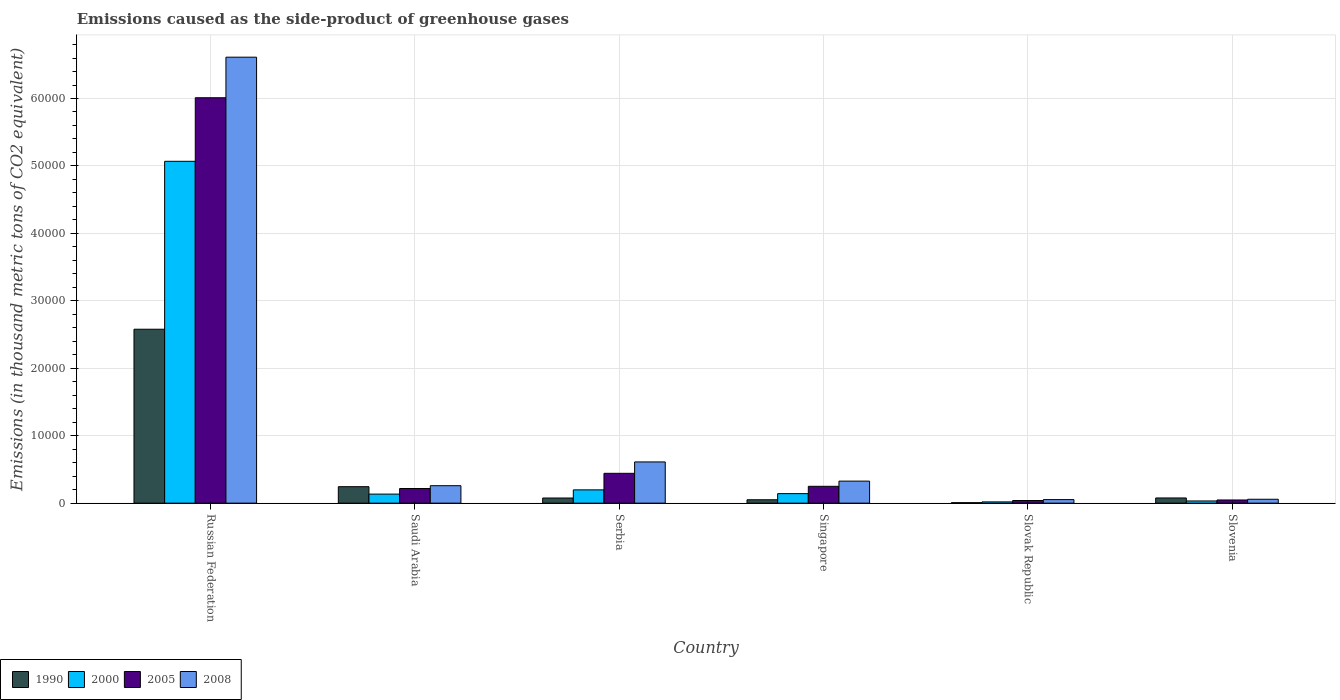How many different coloured bars are there?
Offer a terse response. 4. How many groups of bars are there?
Offer a very short reply. 6. Are the number of bars on each tick of the X-axis equal?
Offer a very short reply. Yes. What is the label of the 6th group of bars from the left?
Your response must be concise. Slovenia. In how many cases, is the number of bars for a given country not equal to the number of legend labels?
Provide a short and direct response. 0. What is the emissions caused as the side-product of greenhouse gases in 1990 in Slovak Republic?
Provide a succinct answer. 68.3. Across all countries, what is the maximum emissions caused as the side-product of greenhouse gases in 2000?
Your answer should be compact. 5.07e+04. Across all countries, what is the minimum emissions caused as the side-product of greenhouse gases in 2005?
Offer a terse response. 391.3. In which country was the emissions caused as the side-product of greenhouse gases in 1990 maximum?
Offer a very short reply. Russian Federation. In which country was the emissions caused as the side-product of greenhouse gases in 2008 minimum?
Your response must be concise. Slovak Republic. What is the total emissions caused as the side-product of greenhouse gases in 2000 in the graph?
Keep it short and to the point. 5.59e+04. What is the difference between the emissions caused as the side-product of greenhouse gases in 2008 in Serbia and that in Slovak Republic?
Your response must be concise. 5585.5. What is the difference between the emissions caused as the side-product of greenhouse gases in 2000 in Russian Federation and the emissions caused as the side-product of greenhouse gases in 2005 in Serbia?
Provide a succinct answer. 4.63e+04. What is the average emissions caused as the side-product of greenhouse gases in 1990 per country?
Your answer should be very brief. 5055.2. What is the difference between the emissions caused as the side-product of greenhouse gases of/in 2000 and emissions caused as the side-product of greenhouse gases of/in 1990 in Singapore?
Provide a succinct answer. 908.1. In how many countries, is the emissions caused as the side-product of greenhouse gases in 2005 greater than 6000 thousand metric tons?
Offer a terse response. 1. What is the ratio of the emissions caused as the side-product of greenhouse gases in 2008 in Russian Federation to that in Singapore?
Provide a succinct answer. 20.24. What is the difference between the highest and the second highest emissions caused as the side-product of greenhouse gases in 1990?
Give a very brief answer. -2.33e+04. What is the difference between the highest and the lowest emissions caused as the side-product of greenhouse gases in 2005?
Make the answer very short. 5.97e+04. Is the sum of the emissions caused as the side-product of greenhouse gases in 2008 in Saudi Arabia and Singapore greater than the maximum emissions caused as the side-product of greenhouse gases in 2005 across all countries?
Your answer should be very brief. No. Is it the case that in every country, the sum of the emissions caused as the side-product of greenhouse gases in 2008 and emissions caused as the side-product of greenhouse gases in 2000 is greater than the sum of emissions caused as the side-product of greenhouse gases in 1990 and emissions caused as the side-product of greenhouse gases in 2005?
Provide a succinct answer. No. What does the 2nd bar from the right in Slovak Republic represents?
Make the answer very short. 2005. How many bars are there?
Provide a short and direct response. 24. How many countries are there in the graph?
Ensure brevity in your answer.  6. Does the graph contain grids?
Provide a succinct answer. Yes. Where does the legend appear in the graph?
Give a very brief answer. Bottom left. How are the legend labels stacked?
Provide a succinct answer. Horizontal. What is the title of the graph?
Offer a very short reply. Emissions caused as the side-product of greenhouse gases. Does "1988" appear as one of the legend labels in the graph?
Your answer should be compact. No. What is the label or title of the X-axis?
Provide a short and direct response. Country. What is the label or title of the Y-axis?
Your answer should be very brief. Emissions (in thousand metric tons of CO2 equivalent). What is the Emissions (in thousand metric tons of CO2 equivalent) in 1990 in Russian Federation?
Your response must be concise. 2.58e+04. What is the Emissions (in thousand metric tons of CO2 equivalent) in 2000 in Russian Federation?
Offer a very short reply. 5.07e+04. What is the Emissions (in thousand metric tons of CO2 equivalent) of 2005 in Russian Federation?
Your answer should be very brief. 6.01e+04. What is the Emissions (in thousand metric tons of CO2 equivalent) in 2008 in Russian Federation?
Offer a very short reply. 6.61e+04. What is the Emissions (in thousand metric tons of CO2 equivalent) of 1990 in Saudi Arabia?
Your response must be concise. 2441.4. What is the Emissions (in thousand metric tons of CO2 equivalent) of 2000 in Saudi Arabia?
Your answer should be very brief. 1340.1. What is the Emissions (in thousand metric tons of CO2 equivalent) in 2005 in Saudi Arabia?
Give a very brief answer. 2170.7. What is the Emissions (in thousand metric tons of CO2 equivalent) of 2008 in Saudi Arabia?
Your response must be concise. 2588.3. What is the Emissions (in thousand metric tons of CO2 equivalent) of 1990 in Serbia?
Keep it short and to the point. 762.4. What is the Emissions (in thousand metric tons of CO2 equivalent) of 2000 in Serbia?
Make the answer very short. 1968.1. What is the Emissions (in thousand metric tons of CO2 equivalent) of 2005 in Serbia?
Make the answer very short. 4422.8. What is the Emissions (in thousand metric tons of CO2 equivalent) in 2008 in Serbia?
Offer a terse response. 6111.3. What is the Emissions (in thousand metric tons of CO2 equivalent) in 1990 in Singapore?
Offer a very short reply. 501.5. What is the Emissions (in thousand metric tons of CO2 equivalent) in 2000 in Singapore?
Your answer should be compact. 1409.6. What is the Emissions (in thousand metric tons of CO2 equivalent) of 2005 in Singapore?
Your response must be concise. 2496.4. What is the Emissions (in thousand metric tons of CO2 equivalent) of 2008 in Singapore?
Offer a very short reply. 3266.4. What is the Emissions (in thousand metric tons of CO2 equivalent) in 1990 in Slovak Republic?
Your answer should be very brief. 68.3. What is the Emissions (in thousand metric tons of CO2 equivalent) in 2000 in Slovak Republic?
Give a very brief answer. 185.6. What is the Emissions (in thousand metric tons of CO2 equivalent) in 2005 in Slovak Republic?
Give a very brief answer. 391.3. What is the Emissions (in thousand metric tons of CO2 equivalent) in 2008 in Slovak Republic?
Ensure brevity in your answer.  525.8. What is the Emissions (in thousand metric tons of CO2 equivalent) of 1990 in Slovenia?
Keep it short and to the point. 769. What is the Emissions (in thousand metric tons of CO2 equivalent) of 2000 in Slovenia?
Keep it short and to the point. 323.3. What is the Emissions (in thousand metric tons of CO2 equivalent) in 2005 in Slovenia?
Make the answer very short. 468.9. What is the Emissions (in thousand metric tons of CO2 equivalent) in 2008 in Slovenia?
Offer a terse response. 576.7. Across all countries, what is the maximum Emissions (in thousand metric tons of CO2 equivalent) of 1990?
Keep it short and to the point. 2.58e+04. Across all countries, what is the maximum Emissions (in thousand metric tons of CO2 equivalent) in 2000?
Provide a short and direct response. 5.07e+04. Across all countries, what is the maximum Emissions (in thousand metric tons of CO2 equivalent) in 2005?
Ensure brevity in your answer.  6.01e+04. Across all countries, what is the maximum Emissions (in thousand metric tons of CO2 equivalent) in 2008?
Your answer should be very brief. 6.61e+04. Across all countries, what is the minimum Emissions (in thousand metric tons of CO2 equivalent) in 1990?
Give a very brief answer. 68.3. Across all countries, what is the minimum Emissions (in thousand metric tons of CO2 equivalent) in 2000?
Your response must be concise. 185.6. Across all countries, what is the minimum Emissions (in thousand metric tons of CO2 equivalent) of 2005?
Make the answer very short. 391.3. Across all countries, what is the minimum Emissions (in thousand metric tons of CO2 equivalent) of 2008?
Give a very brief answer. 525.8. What is the total Emissions (in thousand metric tons of CO2 equivalent) in 1990 in the graph?
Keep it short and to the point. 3.03e+04. What is the total Emissions (in thousand metric tons of CO2 equivalent) in 2000 in the graph?
Your response must be concise. 5.59e+04. What is the total Emissions (in thousand metric tons of CO2 equivalent) of 2005 in the graph?
Your answer should be compact. 7.01e+04. What is the total Emissions (in thousand metric tons of CO2 equivalent) of 2008 in the graph?
Provide a short and direct response. 7.92e+04. What is the difference between the Emissions (in thousand metric tons of CO2 equivalent) in 1990 in Russian Federation and that in Saudi Arabia?
Your answer should be compact. 2.33e+04. What is the difference between the Emissions (in thousand metric tons of CO2 equivalent) of 2000 in Russian Federation and that in Saudi Arabia?
Provide a short and direct response. 4.93e+04. What is the difference between the Emissions (in thousand metric tons of CO2 equivalent) in 2005 in Russian Federation and that in Saudi Arabia?
Offer a terse response. 5.79e+04. What is the difference between the Emissions (in thousand metric tons of CO2 equivalent) in 2008 in Russian Federation and that in Saudi Arabia?
Provide a succinct answer. 6.35e+04. What is the difference between the Emissions (in thousand metric tons of CO2 equivalent) in 1990 in Russian Federation and that in Serbia?
Make the answer very short. 2.50e+04. What is the difference between the Emissions (in thousand metric tons of CO2 equivalent) of 2000 in Russian Federation and that in Serbia?
Give a very brief answer. 4.87e+04. What is the difference between the Emissions (in thousand metric tons of CO2 equivalent) of 2005 in Russian Federation and that in Serbia?
Keep it short and to the point. 5.57e+04. What is the difference between the Emissions (in thousand metric tons of CO2 equivalent) of 2008 in Russian Federation and that in Serbia?
Keep it short and to the point. 6.00e+04. What is the difference between the Emissions (in thousand metric tons of CO2 equivalent) of 1990 in Russian Federation and that in Singapore?
Give a very brief answer. 2.53e+04. What is the difference between the Emissions (in thousand metric tons of CO2 equivalent) in 2000 in Russian Federation and that in Singapore?
Ensure brevity in your answer.  4.93e+04. What is the difference between the Emissions (in thousand metric tons of CO2 equivalent) in 2005 in Russian Federation and that in Singapore?
Provide a short and direct response. 5.76e+04. What is the difference between the Emissions (in thousand metric tons of CO2 equivalent) in 2008 in Russian Federation and that in Singapore?
Offer a very short reply. 6.29e+04. What is the difference between the Emissions (in thousand metric tons of CO2 equivalent) in 1990 in Russian Federation and that in Slovak Republic?
Provide a succinct answer. 2.57e+04. What is the difference between the Emissions (in thousand metric tons of CO2 equivalent) in 2000 in Russian Federation and that in Slovak Republic?
Keep it short and to the point. 5.05e+04. What is the difference between the Emissions (in thousand metric tons of CO2 equivalent) in 2005 in Russian Federation and that in Slovak Republic?
Ensure brevity in your answer.  5.97e+04. What is the difference between the Emissions (in thousand metric tons of CO2 equivalent) of 2008 in Russian Federation and that in Slovak Republic?
Give a very brief answer. 6.56e+04. What is the difference between the Emissions (in thousand metric tons of CO2 equivalent) of 1990 in Russian Federation and that in Slovenia?
Provide a short and direct response. 2.50e+04. What is the difference between the Emissions (in thousand metric tons of CO2 equivalent) in 2000 in Russian Federation and that in Slovenia?
Offer a terse response. 5.04e+04. What is the difference between the Emissions (in thousand metric tons of CO2 equivalent) in 2005 in Russian Federation and that in Slovenia?
Provide a short and direct response. 5.96e+04. What is the difference between the Emissions (in thousand metric tons of CO2 equivalent) in 2008 in Russian Federation and that in Slovenia?
Keep it short and to the point. 6.56e+04. What is the difference between the Emissions (in thousand metric tons of CO2 equivalent) of 1990 in Saudi Arabia and that in Serbia?
Keep it short and to the point. 1679. What is the difference between the Emissions (in thousand metric tons of CO2 equivalent) in 2000 in Saudi Arabia and that in Serbia?
Ensure brevity in your answer.  -628. What is the difference between the Emissions (in thousand metric tons of CO2 equivalent) in 2005 in Saudi Arabia and that in Serbia?
Make the answer very short. -2252.1. What is the difference between the Emissions (in thousand metric tons of CO2 equivalent) in 2008 in Saudi Arabia and that in Serbia?
Provide a succinct answer. -3523. What is the difference between the Emissions (in thousand metric tons of CO2 equivalent) of 1990 in Saudi Arabia and that in Singapore?
Offer a very short reply. 1939.9. What is the difference between the Emissions (in thousand metric tons of CO2 equivalent) of 2000 in Saudi Arabia and that in Singapore?
Provide a succinct answer. -69.5. What is the difference between the Emissions (in thousand metric tons of CO2 equivalent) of 2005 in Saudi Arabia and that in Singapore?
Offer a very short reply. -325.7. What is the difference between the Emissions (in thousand metric tons of CO2 equivalent) of 2008 in Saudi Arabia and that in Singapore?
Offer a terse response. -678.1. What is the difference between the Emissions (in thousand metric tons of CO2 equivalent) in 1990 in Saudi Arabia and that in Slovak Republic?
Provide a short and direct response. 2373.1. What is the difference between the Emissions (in thousand metric tons of CO2 equivalent) of 2000 in Saudi Arabia and that in Slovak Republic?
Offer a very short reply. 1154.5. What is the difference between the Emissions (in thousand metric tons of CO2 equivalent) of 2005 in Saudi Arabia and that in Slovak Republic?
Your answer should be very brief. 1779.4. What is the difference between the Emissions (in thousand metric tons of CO2 equivalent) of 2008 in Saudi Arabia and that in Slovak Republic?
Give a very brief answer. 2062.5. What is the difference between the Emissions (in thousand metric tons of CO2 equivalent) in 1990 in Saudi Arabia and that in Slovenia?
Provide a short and direct response. 1672.4. What is the difference between the Emissions (in thousand metric tons of CO2 equivalent) of 2000 in Saudi Arabia and that in Slovenia?
Your answer should be compact. 1016.8. What is the difference between the Emissions (in thousand metric tons of CO2 equivalent) in 2005 in Saudi Arabia and that in Slovenia?
Your answer should be very brief. 1701.8. What is the difference between the Emissions (in thousand metric tons of CO2 equivalent) of 2008 in Saudi Arabia and that in Slovenia?
Your answer should be compact. 2011.6. What is the difference between the Emissions (in thousand metric tons of CO2 equivalent) in 1990 in Serbia and that in Singapore?
Your answer should be very brief. 260.9. What is the difference between the Emissions (in thousand metric tons of CO2 equivalent) of 2000 in Serbia and that in Singapore?
Ensure brevity in your answer.  558.5. What is the difference between the Emissions (in thousand metric tons of CO2 equivalent) of 2005 in Serbia and that in Singapore?
Provide a short and direct response. 1926.4. What is the difference between the Emissions (in thousand metric tons of CO2 equivalent) of 2008 in Serbia and that in Singapore?
Keep it short and to the point. 2844.9. What is the difference between the Emissions (in thousand metric tons of CO2 equivalent) of 1990 in Serbia and that in Slovak Republic?
Offer a terse response. 694.1. What is the difference between the Emissions (in thousand metric tons of CO2 equivalent) of 2000 in Serbia and that in Slovak Republic?
Offer a very short reply. 1782.5. What is the difference between the Emissions (in thousand metric tons of CO2 equivalent) in 2005 in Serbia and that in Slovak Republic?
Make the answer very short. 4031.5. What is the difference between the Emissions (in thousand metric tons of CO2 equivalent) in 2008 in Serbia and that in Slovak Republic?
Your answer should be compact. 5585.5. What is the difference between the Emissions (in thousand metric tons of CO2 equivalent) of 1990 in Serbia and that in Slovenia?
Give a very brief answer. -6.6. What is the difference between the Emissions (in thousand metric tons of CO2 equivalent) of 2000 in Serbia and that in Slovenia?
Provide a succinct answer. 1644.8. What is the difference between the Emissions (in thousand metric tons of CO2 equivalent) of 2005 in Serbia and that in Slovenia?
Offer a terse response. 3953.9. What is the difference between the Emissions (in thousand metric tons of CO2 equivalent) of 2008 in Serbia and that in Slovenia?
Your response must be concise. 5534.6. What is the difference between the Emissions (in thousand metric tons of CO2 equivalent) in 1990 in Singapore and that in Slovak Republic?
Provide a short and direct response. 433.2. What is the difference between the Emissions (in thousand metric tons of CO2 equivalent) of 2000 in Singapore and that in Slovak Republic?
Provide a short and direct response. 1224. What is the difference between the Emissions (in thousand metric tons of CO2 equivalent) of 2005 in Singapore and that in Slovak Republic?
Provide a succinct answer. 2105.1. What is the difference between the Emissions (in thousand metric tons of CO2 equivalent) of 2008 in Singapore and that in Slovak Republic?
Make the answer very short. 2740.6. What is the difference between the Emissions (in thousand metric tons of CO2 equivalent) in 1990 in Singapore and that in Slovenia?
Your answer should be very brief. -267.5. What is the difference between the Emissions (in thousand metric tons of CO2 equivalent) in 2000 in Singapore and that in Slovenia?
Provide a short and direct response. 1086.3. What is the difference between the Emissions (in thousand metric tons of CO2 equivalent) in 2005 in Singapore and that in Slovenia?
Provide a short and direct response. 2027.5. What is the difference between the Emissions (in thousand metric tons of CO2 equivalent) of 2008 in Singapore and that in Slovenia?
Keep it short and to the point. 2689.7. What is the difference between the Emissions (in thousand metric tons of CO2 equivalent) of 1990 in Slovak Republic and that in Slovenia?
Provide a short and direct response. -700.7. What is the difference between the Emissions (in thousand metric tons of CO2 equivalent) of 2000 in Slovak Republic and that in Slovenia?
Your answer should be very brief. -137.7. What is the difference between the Emissions (in thousand metric tons of CO2 equivalent) in 2005 in Slovak Republic and that in Slovenia?
Offer a very short reply. -77.6. What is the difference between the Emissions (in thousand metric tons of CO2 equivalent) in 2008 in Slovak Republic and that in Slovenia?
Provide a succinct answer. -50.9. What is the difference between the Emissions (in thousand metric tons of CO2 equivalent) of 1990 in Russian Federation and the Emissions (in thousand metric tons of CO2 equivalent) of 2000 in Saudi Arabia?
Your response must be concise. 2.44e+04. What is the difference between the Emissions (in thousand metric tons of CO2 equivalent) of 1990 in Russian Federation and the Emissions (in thousand metric tons of CO2 equivalent) of 2005 in Saudi Arabia?
Your answer should be compact. 2.36e+04. What is the difference between the Emissions (in thousand metric tons of CO2 equivalent) in 1990 in Russian Federation and the Emissions (in thousand metric tons of CO2 equivalent) in 2008 in Saudi Arabia?
Give a very brief answer. 2.32e+04. What is the difference between the Emissions (in thousand metric tons of CO2 equivalent) in 2000 in Russian Federation and the Emissions (in thousand metric tons of CO2 equivalent) in 2005 in Saudi Arabia?
Make the answer very short. 4.85e+04. What is the difference between the Emissions (in thousand metric tons of CO2 equivalent) in 2000 in Russian Federation and the Emissions (in thousand metric tons of CO2 equivalent) in 2008 in Saudi Arabia?
Your response must be concise. 4.81e+04. What is the difference between the Emissions (in thousand metric tons of CO2 equivalent) of 2005 in Russian Federation and the Emissions (in thousand metric tons of CO2 equivalent) of 2008 in Saudi Arabia?
Make the answer very short. 5.75e+04. What is the difference between the Emissions (in thousand metric tons of CO2 equivalent) in 1990 in Russian Federation and the Emissions (in thousand metric tons of CO2 equivalent) in 2000 in Serbia?
Ensure brevity in your answer.  2.38e+04. What is the difference between the Emissions (in thousand metric tons of CO2 equivalent) in 1990 in Russian Federation and the Emissions (in thousand metric tons of CO2 equivalent) in 2005 in Serbia?
Provide a short and direct response. 2.14e+04. What is the difference between the Emissions (in thousand metric tons of CO2 equivalent) in 1990 in Russian Federation and the Emissions (in thousand metric tons of CO2 equivalent) in 2008 in Serbia?
Your response must be concise. 1.97e+04. What is the difference between the Emissions (in thousand metric tons of CO2 equivalent) in 2000 in Russian Federation and the Emissions (in thousand metric tons of CO2 equivalent) in 2005 in Serbia?
Your response must be concise. 4.63e+04. What is the difference between the Emissions (in thousand metric tons of CO2 equivalent) in 2000 in Russian Federation and the Emissions (in thousand metric tons of CO2 equivalent) in 2008 in Serbia?
Offer a very short reply. 4.46e+04. What is the difference between the Emissions (in thousand metric tons of CO2 equivalent) in 2005 in Russian Federation and the Emissions (in thousand metric tons of CO2 equivalent) in 2008 in Serbia?
Provide a succinct answer. 5.40e+04. What is the difference between the Emissions (in thousand metric tons of CO2 equivalent) in 1990 in Russian Federation and the Emissions (in thousand metric tons of CO2 equivalent) in 2000 in Singapore?
Your answer should be very brief. 2.44e+04. What is the difference between the Emissions (in thousand metric tons of CO2 equivalent) of 1990 in Russian Federation and the Emissions (in thousand metric tons of CO2 equivalent) of 2005 in Singapore?
Offer a very short reply. 2.33e+04. What is the difference between the Emissions (in thousand metric tons of CO2 equivalent) in 1990 in Russian Federation and the Emissions (in thousand metric tons of CO2 equivalent) in 2008 in Singapore?
Keep it short and to the point. 2.25e+04. What is the difference between the Emissions (in thousand metric tons of CO2 equivalent) of 2000 in Russian Federation and the Emissions (in thousand metric tons of CO2 equivalent) of 2005 in Singapore?
Make the answer very short. 4.82e+04. What is the difference between the Emissions (in thousand metric tons of CO2 equivalent) in 2000 in Russian Federation and the Emissions (in thousand metric tons of CO2 equivalent) in 2008 in Singapore?
Offer a very short reply. 4.74e+04. What is the difference between the Emissions (in thousand metric tons of CO2 equivalent) of 2005 in Russian Federation and the Emissions (in thousand metric tons of CO2 equivalent) of 2008 in Singapore?
Provide a succinct answer. 5.68e+04. What is the difference between the Emissions (in thousand metric tons of CO2 equivalent) in 1990 in Russian Federation and the Emissions (in thousand metric tons of CO2 equivalent) in 2000 in Slovak Republic?
Make the answer very short. 2.56e+04. What is the difference between the Emissions (in thousand metric tons of CO2 equivalent) in 1990 in Russian Federation and the Emissions (in thousand metric tons of CO2 equivalent) in 2005 in Slovak Republic?
Offer a terse response. 2.54e+04. What is the difference between the Emissions (in thousand metric tons of CO2 equivalent) in 1990 in Russian Federation and the Emissions (in thousand metric tons of CO2 equivalent) in 2008 in Slovak Republic?
Ensure brevity in your answer.  2.53e+04. What is the difference between the Emissions (in thousand metric tons of CO2 equivalent) in 2000 in Russian Federation and the Emissions (in thousand metric tons of CO2 equivalent) in 2005 in Slovak Republic?
Provide a succinct answer. 5.03e+04. What is the difference between the Emissions (in thousand metric tons of CO2 equivalent) in 2000 in Russian Federation and the Emissions (in thousand metric tons of CO2 equivalent) in 2008 in Slovak Republic?
Make the answer very short. 5.02e+04. What is the difference between the Emissions (in thousand metric tons of CO2 equivalent) in 2005 in Russian Federation and the Emissions (in thousand metric tons of CO2 equivalent) in 2008 in Slovak Republic?
Provide a succinct answer. 5.96e+04. What is the difference between the Emissions (in thousand metric tons of CO2 equivalent) of 1990 in Russian Federation and the Emissions (in thousand metric tons of CO2 equivalent) of 2000 in Slovenia?
Offer a very short reply. 2.55e+04. What is the difference between the Emissions (in thousand metric tons of CO2 equivalent) of 1990 in Russian Federation and the Emissions (in thousand metric tons of CO2 equivalent) of 2005 in Slovenia?
Your response must be concise. 2.53e+04. What is the difference between the Emissions (in thousand metric tons of CO2 equivalent) in 1990 in Russian Federation and the Emissions (in thousand metric tons of CO2 equivalent) in 2008 in Slovenia?
Make the answer very short. 2.52e+04. What is the difference between the Emissions (in thousand metric tons of CO2 equivalent) in 2000 in Russian Federation and the Emissions (in thousand metric tons of CO2 equivalent) in 2005 in Slovenia?
Provide a short and direct response. 5.02e+04. What is the difference between the Emissions (in thousand metric tons of CO2 equivalent) in 2000 in Russian Federation and the Emissions (in thousand metric tons of CO2 equivalent) in 2008 in Slovenia?
Give a very brief answer. 5.01e+04. What is the difference between the Emissions (in thousand metric tons of CO2 equivalent) of 2005 in Russian Federation and the Emissions (in thousand metric tons of CO2 equivalent) of 2008 in Slovenia?
Offer a terse response. 5.95e+04. What is the difference between the Emissions (in thousand metric tons of CO2 equivalent) of 1990 in Saudi Arabia and the Emissions (in thousand metric tons of CO2 equivalent) of 2000 in Serbia?
Your answer should be compact. 473.3. What is the difference between the Emissions (in thousand metric tons of CO2 equivalent) of 1990 in Saudi Arabia and the Emissions (in thousand metric tons of CO2 equivalent) of 2005 in Serbia?
Provide a short and direct response. -1981.4. What is the difference between the Emissions (in thousand metric tons of CO2 equivalent) of 1990 in Saudi Arabia and the Emissions (in thousand metric tons of CO2 equivalent) of 2008 in Serbia?
Your response must be concise. -3669.9. What is the difference between the Emissions (in thousand metric tons of CO2 equivalent) in 2000 in Saudi Arabia and the Emissions (in thousand metric tons of CO2 equivalent) in 2005 in Serbia?
Your answer should be very brief. -3082.7. What is the difference between the Emissions (in thousand metric tons of CO2 equivalent) of 2000 in Saudi Arabia and the Emissions (in thousand metric tons of CO2 equivalent) of 2008 in Serbia?
Your answer should be very brief. -4771.2. What is the difference between the Emissions (in thousand metric tons of CO2 equivalent) of 2005 in Saudi Arabia and the Emissions (in thousand metric tons of CO2 equivalent) of 2008 in Serbia?
Provide a succinct answer. -3940.6. What is the difference between the Emissions (in thousand metric tons of CO2 equivalent) of 1990 in Saudi Arabia and the Emissions (in thousand metric tons of CO2 equivalent) of 2000 in Singapore?
Offer a terse response. 1031.8. What is the difference between the Emissions (in thousand metric tons of CO2 equivalent) in 1990 in Saudi Arabia and the Emissions (in thousand metric tons of CO2 equivalent) in 2005 in Singapore?
Provide a succinct answer. -55. What is the difference between the Emissions (in thousand metric tons of CO2 equivalent) in 1990 in Saudi Arabia and the Emissions (in thousand metric tons of CO2 equivalent) in 2008 in Singapore?
Your response must be concise. -825. What is the difference between the Emissions (in thousand metric tons of CO2 equivalent) in 2000 in Saudi Arabia and the Emissions (in thousand metric tons of CO2 equivalent) in 2005 in Singapore?
Offer a very short reply. -1156.3. What is the difference between the Emissions (in thousand metric tons of CO2 equivalent) in 2000 in Saudi Arabia and the Emissions (in thousand metric tons of CO2 equivalent) in 2008 in Singapore?
Provide a short and direct response. -1926.3. What is the difference between the Emissions (in thousand metric tons of CO2 equivalent) of 2005 in Saudi Arabia and the Emissions (in thousand metric tons of CO2 equivalent) of 2008 in Singapore?
Provide a succinct answer. -1095.7. What is the difference between the Emissions (in thousand metric tons of CO2 equivalent) of 1990 in Saudi Arabia and the Emissions (in thousand metric tons of CO2 equivalent) of 2000 in Slovak Republic?
Keep it short and to the point. 2255.8. What is the difference between the Emissions (in thousand metric tons of CO2 equivalent) of 1990 in Saudi Arabia and the Emissions (in thousand metric tons of CO2 equivalent) of 2005 in Slovak Republic?
Keep it short and to the point. 2050.1. What is the difference between the Emissions (in thousand metric tons of CO2 equivalent) of 1990 in Saudi Arabia and the Emissions (in thousand metric tons of CO2 equivalent) of 2008 in Slovak Republic?
Provide a succinct answer. 1915.6. What is the difference between the Emissions (in thousand metric tons of CO2 equivalent) of 2000 in Saudi Arabia and the Emissions (in thousand metric tons of CO2 equivalent) of 2005 in Slovak Republic?
Offer a terse response. 948.8. What is the difference between the Emissions (in thousand metric tons of CO2 equivalent) in 2000 in Saudi Arabia and the Emissions (in thousand metric tons of CO2 equivalent) in 2008 in Slovak Republic?
Your answer should be compact. 814.3. What is the difference between the Emissions (in thousand metric tons of CO2 equivalent) in 2005 in Saudi Arabia and the Emissions (in thousand metric tons of CO2 equivalent) in 2008 in Slovak Republic?
Give a very brief answer. 1644.9. What is the difference between the Emissions (in thousand metric tons of CO2 equivalent) of 1990 in Saudi Arabia and the Emissions (in thousand metric tons of CO2 equivalent) of 2000 in Slovenia?
Provide a succinct answer. 2118.1. What is the difference between the Emissions (in thousand metric tons of CO2 equivalent) in 1990 in Saudi Arabia and the Emissions (in thousand metric tons of CO2 equivalent) in 2005 in Slovenia?
Make the answer very short. 1972.5. What is the difference between the Emissions (in thousand metric tons of CO2 equivalent) in 1990 in Saudi Arabia and the Emissions (in thousand metric tons of CO2 equivalent) in 2008 in Slovenia?
Make the answer very short. 1864.7. What is the difference between the Emissions (in thousand metric tons of CO2 equivalent) of 2000 in Saudi Arabia and the Emissions (in thousand metric tons of CO2 equivalent) of 2005 in Slovenia?
Your answer should be very brief. 871.2. What is the difference between the Emissions (in thousand metric tons of CO2 equivalent) in 2000 in Saudi Arabia and the Emissions (in thousand metric tons of CO2 equivalent) in 2008 in Slovenia?
Your response must be concise. 763.4. What is the difference between the Emissions (in thousand metric tons of CO2 equivalent) in 2005 in Saudi Arabia and the Emissions (in thousand metric tons of CO2 equivalent) in 2008 in Slovenia?
Give a very brief answer. 1594. What is the difference between the Emissions (in thousand metric tons of CO2 equivalent) in 1990 in Serbia and the Emissions (in thousand metric tons of CO2 equivalent) in 2000 in Singapore?
Give a very brief answer. -647.2. What is the difference between the Emissions (in thousand metric tons of CO2 equivalent) of 1990 in Serbia and the Emissions (in thousand metric tons of CO2 equivalent) of 2005 in Singapore?
Provide a succinct answer. -1734. What is the difference between the Emissions (in thousand metric tons of CO2 equivalent) of 1990 in Serbia and the Emissions (in thousand metric tons of CO2 equivalent) of 2008 in Singapore?
Ensure brevity in your answer.  -2504. What is the difference between the Emissions (in thousand metric tons of CO2 equivalent) in 2000 in Serbia and the Emissions (in thousand metric tons of CO2 equivalent) in 2005 in Singapore?
Your answer should be very brief. -528.3. What is the difference between the Emissions (in thousand metric tons of CO2 equivalent) in 2000 in Serbia and the Emissions (in thousand metric tons of CO2 equivalent) in 2008 in Singapore?
Provide a succinct answer. -1298.3. What is the difference between the Emissions (in thousand metric tons of CO2 equivalent) of 2005 in Serbia and the Emissions (in thousand metric tons of CO2 equivalent) of 2008 in Singapore?
Give a very brief answer. 1156.4. What is the difference between the Emissions (in thousand metric tons of CO2 equivalent) in 1990 in Serbia and the Emissions (in thousand metric tons of CO2 equivalent) in 2000 in Slovak Republic?
Provide a succinct answer. 576.8. What is the difference between the Emissions (in thousand metric tons of CO2 equivalent) in 1990 in Serbia and the Emissions (in thousand metric tons of CO2 equivalent) in 2005 in Slovak Republic?
Your answer should be very brief. 371.1. What is the difference between the Emissions (in thousand metric tons of CO2 equivalent) of 1990 in Serbia and the Emissions (in thousand metric tons of CO2 equivalent) of 2008 in Slovak Republic?
Keep it short and to the point. 236.6. What is the difference between the Emissions (in thousand metric tons of CO2 equivalent) in 2000 in Serbia and the Emissions (in thousand metric tons of CO2 equivalent) in 2005 in Slovak Republic?
Your answer should be compact. 1576.8. What is the difference between the Emissions (in thousand metric tons of CO2 equivalent) in 2000 in Serbia and the Emissions (in thousand metric tons of CO2 equivalent) in 2008 in Slovak Republic?
Offer a terse response. 1442.3. What is the difference between the Emissions (in thousand metric tons of CO2 equivalent) in 2005 in Serbia and the Emissions (in thousand metric tons of CO2 equivalent) in 2008 in Slovak Republic?
Offer a very short reply. 3897. What is the difference between the Emissions (in thousand metric tons of CO2 equivalent) of 1990 in Serbia and the Emissions (in thousand metric tons of CO2 equivalent) of 2000 in Slovenia?
Your response must be concise. 439.1. What is the difference between the Emissions (in thousand metric tons of CO2 equivalent) of 1990 in Serbia and the Emissions (in thousand metric tons of CO2 equivalent) of 2005 in Slovenia?
Keep it short and to the point. 293.5. What is the difference between the Emissions (in thousand metric tons of CO2 equivalent) in 1990 in Serbia and the Emissions (in thousand metric tons of CO2 equivalent) in 2008 in Slovenia?
Offer a very short reply. 185.7. What is the difference between the Emissions (in thousand metric tons of CO2 equivalent) in 2000 in Serbia and the Emissions (in thousand metric tons of CO2 equivalent) in 2005 in Slovenia?
Provide a succinct answer. 1499.2. What is the difference between the Emissions (in thousand metric tons of CO2 equivalent) in 2000 in Serbia and the Emissions (in thousand metric tons of CO2 equivalent) in 2008 in Slovenia?
Offer a very short reply. 1391.4. What is the difference between the Emissions (in thousand metric tons of CO2 equivalent) in 2005 in Serbia and the Emissions (in thousand metric tons of CO2 equivalent) in 2008 in Slovenia?
Keep it short and to the point. 3846.1. What is the difference between the Emissions (in thousand metric tons of CO2 equivalent) of 1990 in Singapore and the Emissions (in thousand metric tons of CO2 equivalent) of 2000 in Slovak Republic?
Your response must be concise. 315.9. What is the difference between the Emissions (in thousand metric tons of CO2 equivalent) of 1990 in Singapore and the Emissions (in thousand metric tons of CO2 equivalent) of 2005 in Slovak Republic?
Offer a very short reply. 110.2. What is the difference between the Emissions (in thousand metric tons of CO2 equivalent) of 1990 in Singapore and the Emissions (in thousand metric tons of CO2 equivalent) of 2008 in Slovak Republic?
Offer a very short reply. -24.3. What is the difference between the Emissions (in thousand metric tons of CO2 equivalent) of 2000 in Singapore and the Emissions (in thousand metric tons of CO2 equivalent) of 2005 in Slovak Republic?
Provide a short and direct response. 1018.3. What is the difference between the Emissions (in thousand metric tons of CO2 equivalent) in 2000 in Singapore and the Emissions (in thousand metric tons of CO2 equivalent) in 2008 in Slovak Republic?
Offer a very short reply. 883.8. What is the difference between the Emissions (in thousand metric tons of CO2 equivalent) of 2005 in Singapore and the Emissions (in thousand metric tons of CO2 equivalent) of 2008 in Slovak Republic?
Keep it short and to the point. 1970.6. What is the difference between the Emissions (in thousand metric tons of CO2 equivalent) in 1990 in Singapore and the Emissions (in thousand metric tons of CO2 equivalent) in 2000 in Slovenia?
Your answer should be compact. 178.2. What is the difference between the Emissions (in thousand metric tons of CO2 equivalent) in 1990 in Singapore and the Emissions (in thousand metric tons of CO2 equivalent) in 2005 in Slovenia?
Keep it short and to the point. 32.6. What is the difference between the Emissions (in thousand metric tons of CO2 equivalent) in 1990 in Singapore and the Emissions (in thousand metric tons of CO2 equivalent) in 2008 in Slovenia?
Provide a short and direct response. -75.2. What is the difference between the Emissions (in thousand metric tons of CO2 equivalent) of 2000 in Singapore and the Emissions (in thousand metric tons of CO2 equivalent) of 2005 in Slovenia?
Provide a short and direct response. 940.7. What is the difference between the Emissions (in thousand metric tons of CO2 equivalent) in 2000 in Singapore and the Emissions (in thousand metric tons of CO2 equivalent) in 2008 in Slovenia?
Provide a succinct answer. 832.9. What is the difference between the Emissions (in thousand metric tons of CO2 equivalent) of 2005 in Singapore and the Emissions (in thousand metric tons of CO2 equivalent) of 2008 in Slovenia?
Offer a terse response. 1919.7. What is the difference between the Emissions (in thousand metric tons of CO2 equivalent) in 1990 in Slovak Republic and the Emissions (in thousand metric tons of CO2 equivalent) in 2000 in Slovenia?
Provide a succinct answer. -255. What is the difference between the Emissions (in thousand metric tons of CO2 equivalent) in 1990 in Slovak Republic and the Emissions (in thousand metric tons of CO2 equivalent) in 2005 in Slovenia?
Provide a short and direct response. -400.6. What is the difference between the Emissions (in thousand metric tons of CO2 equivalent) of 1990 in Slovak Republic and the Emissions (in thousand metric tons of CO2 equivalent) of 2008 in Slovenia?
Your answer should be compact. -508.4. What is the difference between the Emissions (in thousand metric tons of CO2 equivalent) in 2000 in Slovak Republic and the Emissions (in thousand metric tons of CO2 equivalent) in 2005 in Slovenia?
Offer a very short reply. -283.3. What is the difference between the Emissions (in thousand metric tons of CO2 equivalent) of 2000 in Slovak Republic and the Emissions (in thousand metric tons of CO2 equivalent) of 2008 in Slovenia?
Keep it short and to the point. -391.1. What is the difference between the Emissions (in thousand metric tons of CO2 equivalent) in 2005 in Slovak Republic and the Emissions (in thousand metric tons of CO2 equivalent) in 2008 in Slovenia?
Offer a terse response. -185.4. What is the average Emissions (in thousand metric tons of CO2 equivalent) of 1990 per country?
Ensure brevity in your answer.  5055.2. What is the average Emissions (in thousand metric tons of CO2 equivalent) of 2000 per country?
Provide a short and direct response. 9319.12. What is the average Emissions (in thousand metric tons of CO2 equivalent) of 2005 per country?
Your answer should be very brief. 1.17e+04. What is the average Emissions (in thousand metric tons of CO2 equivalent) in 2008 per country?
Your answer should be very brief. 1.32e+04. What is the difference between the Emissions (in thousand metric tons of CO2 equivalent) in 1990 and Emissions (in thousand metric tons of CO2 equivalent) in 2000 in Russian Federation?
Your answer should be very brief. -2.49e+04. What is the difference between the Emissions (in thousand metric tons of CO2 equivalent) of 1990 and Emissions (in thousand metric tons of CO2 equivalent) of 2005 in Russian Federation?
Ensure brevity in your answer.  -3.43e+04. What is the difference between the Emissions (in thousand metric tons of CO2 equivalent) of 1990 and Emissions (in thousand metric tons of CO2 equivalent) of 2008 in Russian Federation?
Your response must be concise. -4.03e+04. What is the difference between the Emissions (in thousand metric tons of CO2 equivalent) of 2000 and Emissions (in thousand metric tons of CO2 equivalent) of 2005 in Russian Federation?
Make the answer very short. -9424.5. What is the difference between the Emissions (in thousand metric tons of CO2 equivalent) of 2000 and Emissions (in thousand metric tons of CO2 equivalent) of 2008 in Russian Federation?
Offer a very short reply. -1.54e+04. What is the difference between the Emissions (in thousand metric tons of CO2 equivalent) in 2005 and Emissions (in thousand metric tons of CO2 equivalent) in 2008 in Russian Federation?
Give a very brief answer. -6015. What is the difference between the Emissions (in thousand metric tons of CO2 equivalent) in 1990 and Emissions (in thousand metric tons of CO2 equivalent) in 2000 in Saudi Arabia?
Your response must be concise. 1101.3. What is the difference between the Emissions (in thousand metric tons of CO2 equivalent) in 1990 and Emissions (in thousand metric tons of CO2 equivalent) in 2005 in Saudi Arabia?
Offer a very short reply. 270.7. What is the difference between the Emissions (in thousand metric tons of CO2 equivalent) in 1990 and Emissions (in thousand metric tons of CO2 equivalent) in 2008 in Saudi Arabia?
Your response must be concise. -146.9. What is the difference between the Emissions (in thousand metric tons of CO2 equivalent) in 2000 and Emissions (in thousand metric tons of CO2 equivalent) in 2005 in Saudi Arabia?
Your answer should be very brief. -830.6. What is the difference between the Emissions (in thousand metric tons of CO2 equivalent) of 2000 and Emissions (in thousand metric tons of CO2 equivalent) of 2008 in Saudi Arabia?
Offer a very short reply. -1248.2. What is the difference between the Emissions (in thousand metric tons of CO2 equivalent) of 2005 and Emissions (in thousand metric tons of CO2 equivalent) of 2008 in Saudi Arabia?
Your answer should be very brief. -417.6. What is the difference between the Emissions (in thousand metric tons of CO2 equivalent) in 1990 and Emissions (in thousand metric tons of CO2 equivalent) in 2000 in Serbia?
Provide a succinct answer. -1205.7. What is the difference between the Emissions (in thousand metric tons of CO2 equivalent) of 1990 and Emissions (in thousand metric tons of CO2 equivalent) of 2005 in Serbia?
Offer a very short reply. -3660.4. What is the difference between the Emissions (in thousand metric tons of CO2 equivalent) in 1990 and Emissions (in thousand metric tons of CO2 equivalent) in 2008 in Serbia?
Offer a terse response. -5348.9. What is the difference between the Emissions (in thousand metric tons of CO2 equivalent) in 2000 and Emissions (in thousand metric tons of CO2 equivalent) in 2005 in Serbia?
Give a very brief answer. -2454.7. What is the difference between the Emissions (in thousand metric tons of CO2 equivalent) of 2000 and Emissions (in thousand metric tons of CO2 equivalent) of 2008 in Serbia?
Keep it short and to the point. -4143.2. What is the difference between the Emissions (in thousand metric tons of CO2 equivalent) in 2005 and Emissions (in thousand metric tons of CO2 equivalent) in 2008 in Serbia?
Give a very brief answer. -1688.5. What is the difference between the Emissions (in thousand metric tons of CO2 equivalent) in 1990 and Emissions (in thousand metric tons of CO2 equivalent) in 2000 in Singapore?
Your answer should be very brief. -908.1. What is the difference between the Emissions (in thousand metric tons of CO2 equivalent) in 1990 and Emissions (in thousand metric tons of CO2 equivalent) in 2005 in Singapore?
Provide a succinct answer. -1994.9. What is the difference between the Emissions (in thousand metric tons of CO2 equivalent) of 1990 and Emissions (in thousand metric tons of CO2 equivalent) of 2008 in Singapore?
Your answer should be very brief. -2764.9. What is the difference between the Emissions (in thousand metric tons of CO2 equivalent) in 2000 and Emissions (in thousand metric tons of CO2 equivalent) in 2005 in Singapore?
Make the answer very short. -1086.8. What is the difference between the Emissions (in thousand metric tons of CO2 equivalent) in 2000 and Emissions (in thousand metric tons of CO2 equivalent) in 2008 in Singapore?
Your answer should be very brief. -1856.8. What is the difference between the Emissions (in thousand metric tons of CO2 equivalent) in 2005 and Emissions (in thousand metric tons of CO2 equivalent) in 2008 in Singapore?
Your answer should be compact. -770. What is the difference between the Emissions (in thousand metric tons of CO2 equivalent) in 1990 and Emissions (in thousand metric tons of CO2 equivalent) in 2000 in Slovak Republic?
Keep it short and to the point. -117.3. What is the difference between the Emissions (in thousand metric tons of CO2 equivalent) in 1990 and Emissions (in thousand metric tons of CO2 equivalent) in 2005 in Slovak Republic?
Offer a very short reply. -323. What is the difference between the Emissions (in thousand metric tons of CO2 equivalent) of 1990 and Emissions (in thousand metric tons of CO2 equivalent) of 2008 in Slovak Republic?
Make the answer very short. -457.5. What is the difference between the Emissions (in thousand metric tons of CO2 equivalent) of 2000 and Emissions (in thousand metric tons of CO2 equivalent) of 2005 in Slovak Republic?
Provide a short and direct response. -205.7. What is the difference between the Emissions (in thousand metric tons of CO2 equivalent) of 2000 and Emissions (in thousand metric tons of CO2 equivalent) of 2008 in Slovak Republic?
Your answer should be very brief. -340.2. What is the difference between the Emissions (in thousand metric tons of CO2 equivalent) of 2005 and Emissions (in thousand metric tons of CO2 equivalent) of 2008 in Slovak Republic?
Keep it short and to the point. -134.5. What is the difference between the Emissions (in thousand metric tons of CO2 equivalent) of 1990 and Emissions (in thousand metric tons of CO2 equivalent) of 2000 in Slovenia?
Your answer should be compact. 445.7. What is the difference between the Emissions (in thousand metric tons of CO2 equivalent) of 1990 and Emissions (in thousand metric tons of CO2 equivalent) of 2005 in Slovenia?
Your response must be concise. 300.1. What is the difference between the Emissions (in thousand metric tons of CO2 equivalent) of 1990 and Emissions (in thousand metric tons of CO2 equivalent) of 2008 in Slovenia?
Your answer should be compact. 192.3. What is the difference between the Emissions (in thousand metric tons of CO2 equivalent) of 2000 and Emissions (in thousand metric tons of CO2 equivalent) of 2005 in Slovenia?
Ensure brevity in your answer.  -145.6. What is the difference between the Emissions (in thousand metric tons of CO2 equivalent) in 2000 and Emissions (in thousand metric tons of CO2 equivalent) in 2008 in Slovenia?
Provide a short and direct response. -253.4. What is the difference between the Emissions (in thousand metric tons of CO2 equivalent) in 2005 and Emissions (in thousand metric tons of CO2 equivalent) in 2008 in Slovenia?
Your response must be concise. -107.8. What is the ratio of the Emissions (in thousand metric tons of CO2 equivalent) in 1990 in Russian Federation to that in Saudi Arabia?
Ensure brevity in your answer.  10.56. What is the ratio of the Emissions (in thousand metric tons of CO2 equivalent) of 2000 in Russian Federation to that in Saudi Arabia?
Make the answer very short. 37.82. What is the ratio of the Emissions (in thousand metric tons of CO2 equivalent) in 2005 in Russian Federation to that in Saudi Arabia?
Provide a short and direct response. 27.69. What is the ratio of the Emissions (in thousand metric tons of CO2 equivalent) in 2008 in Russian Federation to that in Saudi Arabia?
Keep it short and to the point. 25.55. What is the ratio of the Emissions (in thousand metric tons of CO2 equivalent) in 1990 in Russian Federation to that in Serbia?
Your answer should be compact. 33.83. What is the ratio of the Emissions (in thousand metric tons of CO2 equivalent) in 2000 in Russian Federation to that in Serbia?
Give a very brief answer. 25.75. What is the ratio of the Emissions (in thousand metric tons of CO2 equivalent) in 2005 in Russian Federation to that in Serbia?
Offer a very short reply. 13.59. What is the ratio of the Emissions (in thousand metric tons of CO2 equivalent) of 2008 in Russian Federation to that in Serbia?
Your answer should be compact. 10.82. What is the ratio of the Emissions (in thousand metric tons of CO2 equivalent) of 1990 in Russian Federation to that in Singapore?
Give a very brief answer. 51.42. What is the ratio of the Emissions (in thousand metric tons of CO2 equivalent) of 2000 in Russian Federation to that in Singapore?
Offer a very short reply. 35.96. What is the ratio of the Emissions (in thousand metric tons of CO2 equivalent) of 2005 in Russian Federation to that in Singapore?
Make the answer very short. 24.08. What is the ratio of the Emissions (in thousand metric tons of CO2 equivalent) in 2008 in Russian Federation to that in Singapore?
Your response must be concise. 20.24. What is the ratio of the Emissions (in thousand metric tons of CO2 equivalent) of 1990 in Russian Federation to that in Slovak Republic?
Provide a succinct answer. 377.58. What is the ratio of the Emissions (in thousand metric tons of CO2 equivalent) of 2000 in Russian Federation to that in Slovak Republic?
Your answer should be compact. 273.1. What is the ratio of the Emissions (in thousand metric tons of CO2 equivalent) in 2005 in Russian Federation to that in Slovak Republic?
Make the answer very short. 153.62. What is the ratio of the Emissions (in thousand metric tons of CO2 equivalent) in 2008 in Russian Federation to that in Slovak Republic?
Your answer should be very brief. 125.77. What is the ratio of the Emissions (in thousand metric tons of CO2 equivalent) of 1990 in Russian Federation to that in Slovenia?
Offer a very short reply. 33.54. What is the ratio of the Emissions (in thousand metric tons of CO2 equivalent) in 2000 in Russian Federation to that in Slovenia?
Your answer should be very brief. 156.78. What is the ratio of the Emissions (in thousand metric tons of CO2 equivalent) of 2005 in Russian Federation to that in Slovenia?
Your response must be concise. 128.2. What is the ratio of the Emissions (in thousand metric tons of CO2 equivalent) of 2008 in Russian Federation to that in Slovenia?
Your answer should be very brief. 114.67. What is the ratio of the Emissions (in thousand metric tons of CO2 equivalent) of 1990 in Saudi Arabia to that in Serbia?
Offer a very short reply. 3.2. What is the ratio of the Emissions (in thousand metric tons of CO2 equivalent) of 2000 in Saudi Arabia to that in Serbia?
Offer a very short reply. 0.68. What is the ratio of the Emissions (in thousand metric tons of CO2 equivalent) of 2005 in Saudi Arabia to that in Serbia?
Provide a succinct answer. 0.49. What is the ratio of the Emissions (in thousand metric tons of CO2 equivalent) in 2008 in Saudi Arabia to that in Serbia?
Your answer should be very brief. 0.42. What is the ratio of the Emissions (in thousand metric tons of CO2 equivalent) in 1990 in Saudi Arabia to that in Singapore?
Your answer should be compact. 4.87. What is the ratio of the Emissions (in thousand metric tons of CO2 equivalent) in 2000 in Saudi Arabia to that in Singapore?
Provide a short and direct response. 0.95. What is the ratio of the Emissions (in thousand metric tons of CO2 equivalent) of 2005 in Saudi Arabia to that in Singapore?
Your answer should be compact. 0.87. What is the ratio of the Emissions (in thousand metric tons of CO2 equivalent) in 2008 in Saudi Arabia to that in Singapore?
Keep it short and to the point. 0.79. What is the ratio of the Emissions (in thousand metric tons of CO2 equivalent) in 1990 in Saudi Arabia to that in Slovak Republic?
Offer a terse response. 35.75. What is the ratio of the Emissions (in thousand metric tons of CO2 equivalent) of 2000 in Saudi Arabia to that in Slovak Republic?
Provide a succinct answer. 7.22. What is the ratio of the Emissions (in thousand metric tons of CO2 equivalent) of 2005 in Saudi Arabia to that in Slovak Republic?
Offer a very short reply. 5.55. What is the ratio of the Emissions (in thousand metric tons of CO2 equivalent) in 2008 in Saudi Arabia to that in Slovak Republic?
Offer a very short reply. 4.92. What is the ratio of the Emissions (in thousand metric tons of CO2 equivalent) in 1990 in Saudi Arabia to that in Slovenia?
Keep it short and to the point. 3.17. What is the ratio of the Emissions (in thousand metric tons of CO2 equivalent) of 2000 in Saudi Arabia to that in Slovenia?
Offer a terse response. 4.15. What is the ratio of the Emissions (in thousand metric tons of CO2 equivalent) of 2005 in Saudi Arabia to that in Slovenia?
Provide a succinct answer. 4.63. What is the ratio of the Emissions (in thousand metric tons of CO2 equivalent) of 2008 in Saudi Arabia to that in Slovenia?
Your response must be concise. 4.49. What is the ratio of the Emissions (in thousand metric tons of CO2 equivalent) in 1990 in Serbia to that in Singapore?
Offer a very short reply. 1.52. What is the ratio of the Emissions (in thousand metric tons of CO2 equivalent) of 2000 in Serbia to that in Singapore?
Offer a terse response. 1.4. What is the ratio of the Emissions (in thousand metric tons of CO2 equivalent) in 2005 in Serbia to that in Singapore?
Give a very brief answer. 1.77. What is the ratio of the Emissions (in thousand metric tons of CO2 equivalent) in 2008 in Serbia to that in Singapore?
Provide a short and direct response. 1.87. What is the ratio of the Emissions (in thousand metric tons of CO2 equivalent) of 1990 in Serbia to that in Slovak Republic?
Your answer should be compact. 11.16. What is the ratio of the Emissions (in thousand metric tons of CO2 equivalent) in 2000 in Serbia to that in Slovak Republic?
Ensure brevity in your answer.  10.6. What is the ratio of the Emissions (in thousand metric tons of CO2 equivalent) in 2005 in Serbia to that in Slovak Republic?
Provide a short and direct response. 11.3. What is the ratio of the Emissions (in thousand metric tons of CO2 equivalent) in 2008 in Serbia to that in Slovak Republic?
Your answer should be compact. 11.62. What is the ratio of the Emissions (in thousand metric tons of CO2 equivalent) of 2000 in Serbia to that in Slovenia?
Your answer should be compact. 6.09. What is the ratio of the Emissions (in thousand metric tons of CO2 equivalent) in 2005 in Serbia to that in Slovenia?
Your response must be concise. 9.43. What is the ratio of the Emissions (in thousand metric tons of CO2 equivalent) in 2008 in Serbia to that in Slovenia?
Your answer should be compact. 10.6. What is the ratio of the Emissions (in thousand metric tons of CO2 equivalent) of 1990 in Singapore to that in Slovak Republic?
Offer a very short reply. 7.34. What is the ratio of the Emissions (in thousand metric tons of CO2 equivalent) of 2000 in Singapore to that in Slovak Republic?
Ensure brevity in your answer.  7.59. What is the ratio of the Emissions (in thousand metric tons of CO2 equivalent) in 2005 in Singapore to that in Slovak Republic?
Ensure brevity in your answer.  6.38. What is the ratio of the Emissions (in thousand metric tons of CO2 equivalent) in 2008 in Singapore to that in Slovak Republic?
Offer a very short reply. 6.21. What is the ratio of the Emissions (in thousand metric tons of CO2 equivalent) in 1990 in Singapore to that in Slovenia?
Give a very brief answer. 0.65. What is the ratio of the Emissions (in thousand metric tons of CO2 equivalent) in 2000 in Singapore to that in Slovenia?
Make the answer very short. 4.36. What is the ratio of the Emissions (in thousand metric tons of CO2 equivalent) in 2005 in Singapore to that in Slovenia?
Your response must be concise. 5.32. What is the ratio of the Emissions (in thousand metric tons of CO2 equivalent) of 2008 in Singapore to that in Slovenia?
Offer a very short reply. 5.66. What is the ratio of the Emissions (in thousand metric tons of CO2 equivalent) of 1990 in Slovak Republic to that in Slovenia?
Offer a very short reply. 0.09. What is the ratio of the Emissions (in thousand metric tons of CO2 equivalent) in 2000 in Slovak Republic to that in Slovenia?
Offer a very short reply. 0.57. What is the ratio of the Emissions (in thousand metric tons of CO2 equivalent) of 2005 in Slovak Republic to that in Slovenia?
Provide a succinct answer. 0.83. What is the ratio of the Emissions (in thousand metric tons of CO2 equivalent) in 2008 in Slovak Republic to that in Slovenia?
Ensure brevity in your answer.  0.91. What is the difference between the highest and the second highest Emissions (in thousand metric tons of CO2 equivalent) of 1990?
Offer a very short reply. 2.33e+04. What is the difference between the highest and the second highest Emissions (in thousand metric tons of CO2 equivalent) of 2000?
Ensure brevity in your answer.  4.87e+04. What is the difference between the highest and the second highest Emissions (in thousand metric tons of CO2 equivalent) of 2005?
Your response must be concise. 5.57e+04. What is the difference between the highest and the second highest Emissions (in thousand metric tons of CO2 equivalent) in 2008?
Offer a very short reply. 6.00e+04. What is the difference between the highest and the lowest Emissions (in thousand metric tons of CO2 equivalent) in 1990?
Offer a very short reply. 2.57e+04. What is the difference between the highest and the lowest Emissions (in thousand metric tons of CO2 equivalent) of 2000?
Offer a very short reply. 5.05e+04. What is the difference between the highest and the lowest Emissions (in thousand metric tons of CO2 equivalent) of 2005?
Your answer should be very brief. 5.97e+04. What is the difference between the highest and the lowest Emissions (in thousand metric tons of CO2 equivalent) of 2008?
Offer a very short reply. 6.56e+04. 